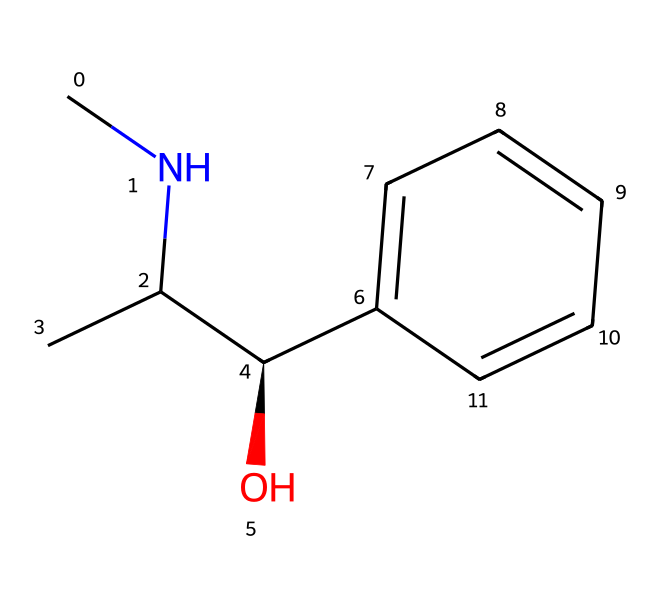What is the molecular formula of ephedrine? By analyzing the SMILES representation, we identify the constituent atoms: there are 10 carbon (C) atoms, 15 hydrogen (H) atoms, and 1 nitrogen (N) atom. Therefore, the molecular formula is derived by counting these atoms.
Answer: C10H15N How many chiral centers are present in ephedrine? The SMILES representation indicates a stereocenter at the carbon connected to the amine and the alcohol (C@H), which indicates one chiral center in the molecule.
Answer: 1 What type of functional group does ephedrine contain? In the structure, we can see the presence of an -OH group, which is characteristic of alcohols. Additionally, there is a nitrogen atom linked to the carbon chain, suggesting an amine functional group. Therefore, ephedrine contains both alcohol and amine functional groups.
Answer: alcohol and amine What is the significance of the nitrogen atom in ephedrine? The nitrogen atom in ephedrine is responsible for its classification as an alkaloid. Alkaloids typically contain nitrogen atoms in their structure, which contributes to their biological activity and effects, such as stimulant properties.
Answer: alkaloid Is ephedrine a saturated or unsaturated compound? The SMILES representation shows the absence of double or triple bonds between carbon atoms, indicating that all carbon bonds are single bonds. This suggests that ephedrine is a saturated compound.
Answer: saturated 